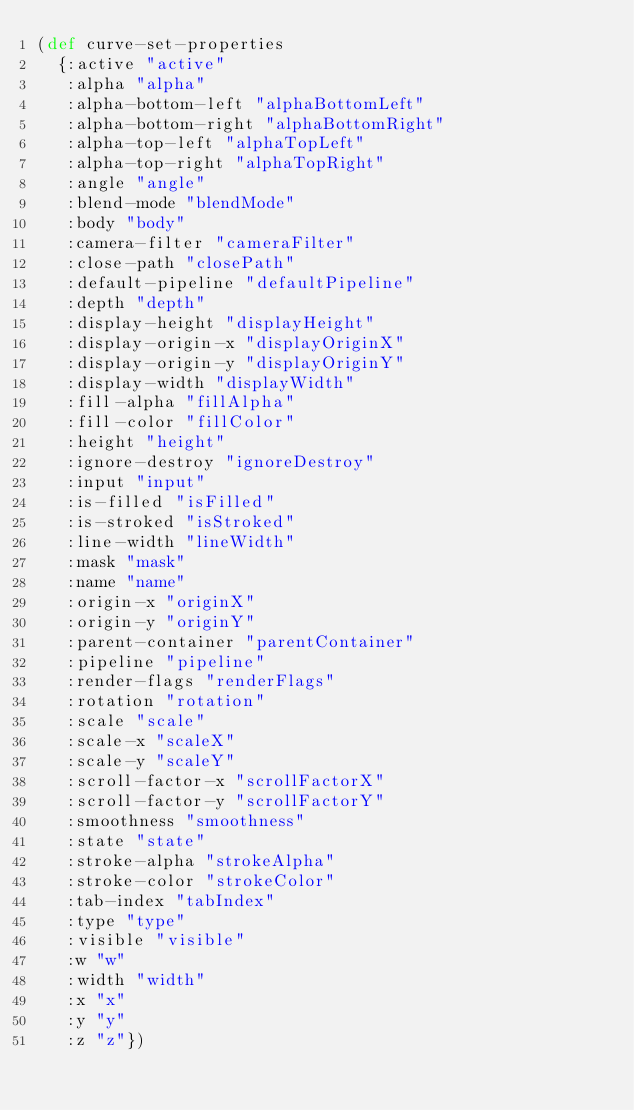Convert code to text. <code><loc_0><loc_0><loc_500><loc_500><_Clojure_>(def curve-set-properties
  {:active "active"
   :alpha "alpha"
   :alpha-bottom-left "alphaBottomLeft"
   :alpha-bottom-right "alphaBottomRight"
   :alpha-top-left "alphaTopLeft"
   :alpha-top-right "alphaTopRight"
   :angle "angle"
   :blend-mode "blendMode"
   :body "body"
   :camera-filter "cameraFilter"
   :close-path "closePath"
   :default-pipeline "defaultPipeline"
   :depth "depth"
   :display-height "displayHeight"
   :display-origin-x "displayOriginX"
   :display-origin-y "displayOriginY"
   :display-width "displayWidth"
   :fill-alpha "fillAlpha"
   :fill-color "fillColor"
   :height "height"
   :ignore-destroy "ignoreDestroy"
   :input "input"
   :is-filled "isFilled"
   :is-stroked "isStroked"
   :line-width "lineWidth"
   :mask "mask"
   :name "name"
   :origin-x "originX"
   :origin-y "originY"
   :parent-container "parentContainer"
   :pipeline "pipeline"
   :render-flags "renderFlags"
   :rotation "rotation"
   :scale "scale"
   :scale-x "scaleX"
   :scale-y "scaleY"
   :scroll-factor-x "scrollFactorX"
   :scroll-factor-y "scrollFactorY"
   :smoothness "smoothness"
   :state "state"
   :stroke-alpha "strokeAlpha"
   :stroke-color "strokeColor"
   :tab-index "tabIndex"
   :type "type"
   :visible "visible"
   :w "w"
   :width "width"
   :x "x"
   :y "y"
   :z "z"})</code> 